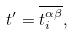<formula> <loc_0><loc_0><loc_500><loc_500>t ^ { \prime } = \overline { t _ { i } ^ { \alpha \beta } } ,</formula> 